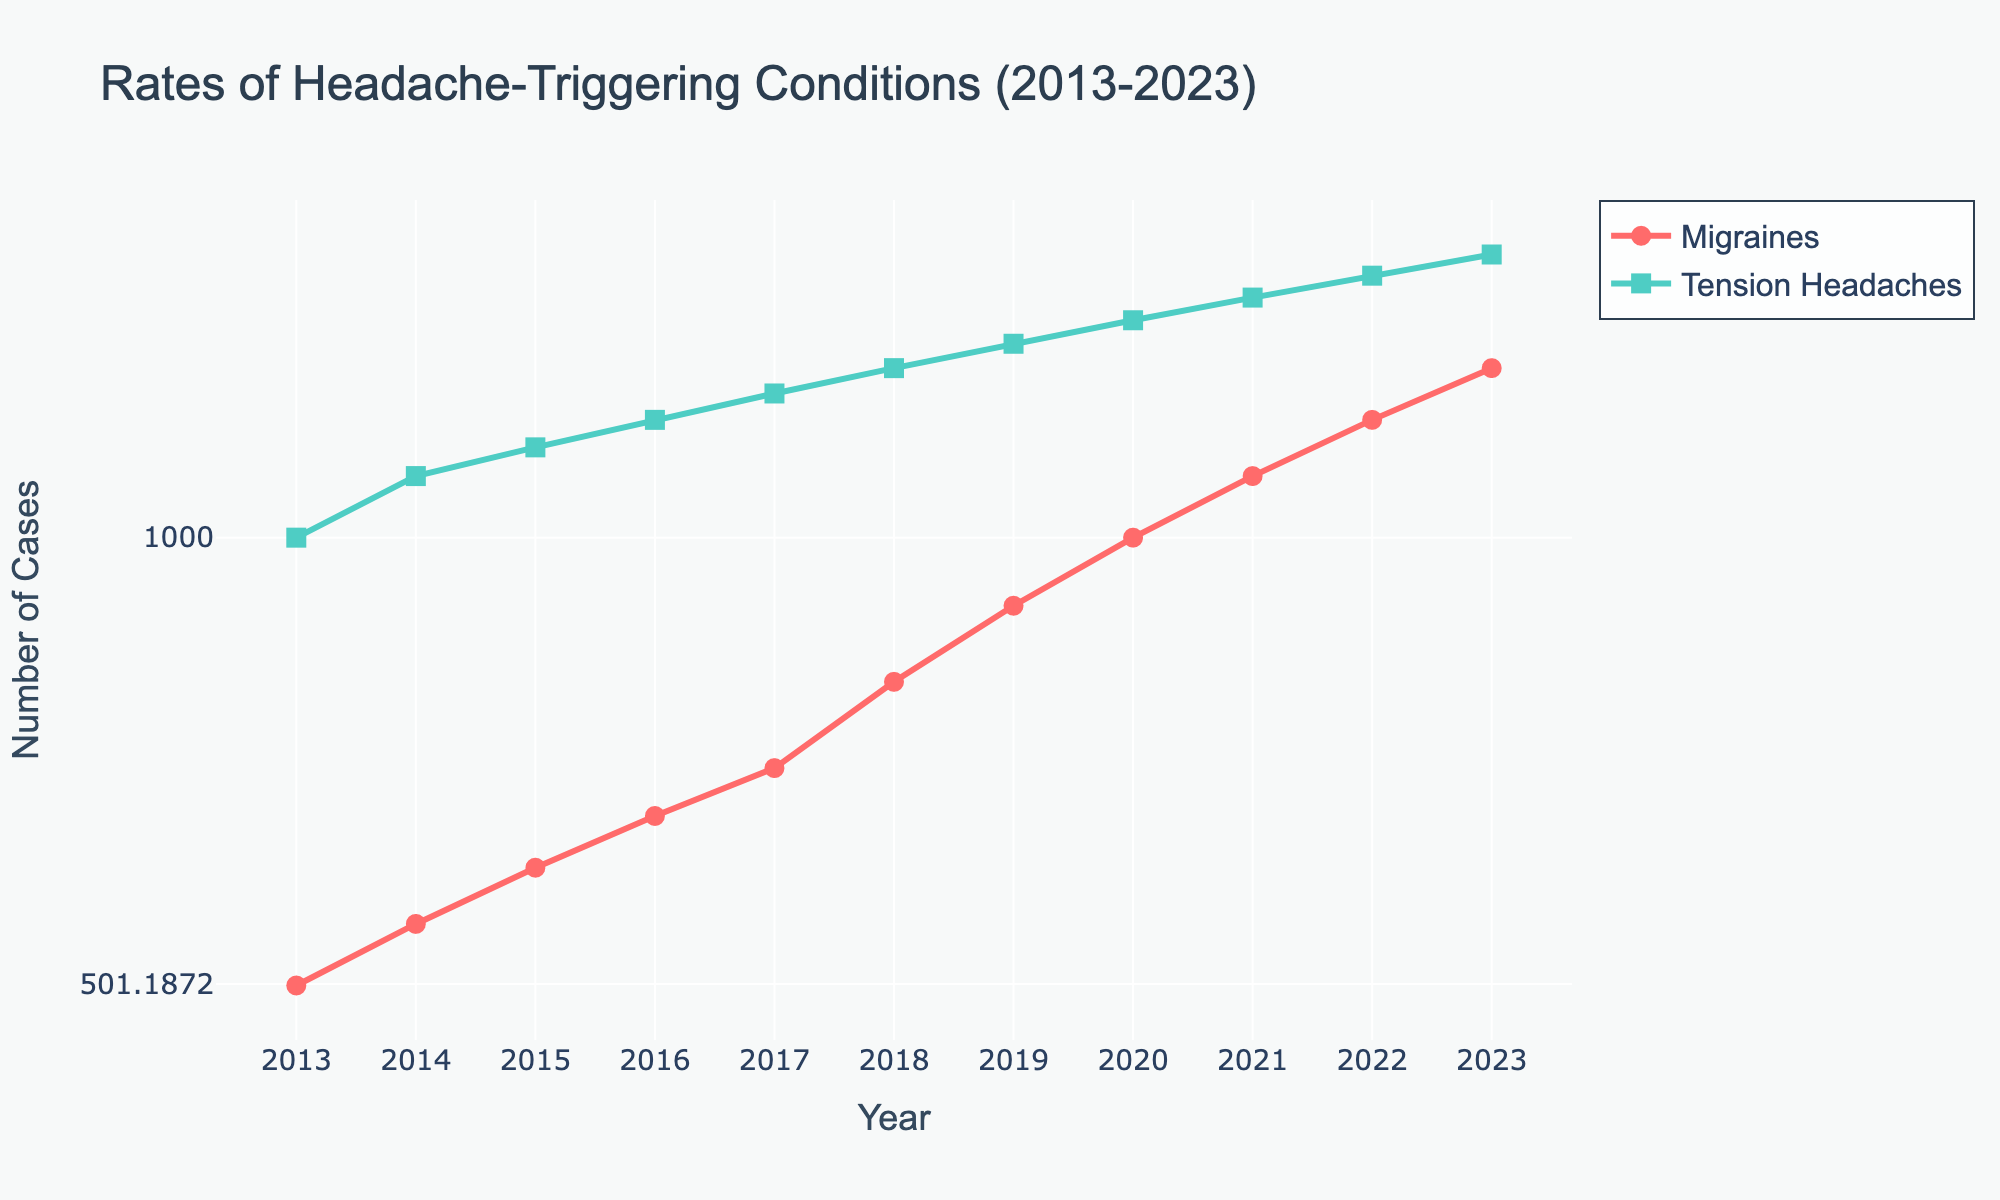What is the trend observed in the rate of migraines from 2013 to 2023? The line plot shows a consistent upward trend in the rate of migraines from 2013 to 2023. The number of cases increases each year as indicated by the data points connected with a line.
Answer: Upward trend What is the title of the figure? The title of the figure is mentioned at the top center of the plot.
Answer: Rates of Headache-Triggering Conditions (2013-2023) Which type of headache had more reported cases in 2017, migraines or tension headaches? By observing the y-values corresponding to 2017 on the respective lines, we see that tension headaches had more reported cases (approximately 1250) compared to migraines (approximately 700).
Answer: Tension headaches By what factor did the number of migraine cases change from 2013 to 2023? The number of migraine cases in 2013 was 500, and in 2023 it was 1300. The factor change is calculated as 1300/500.
Answer: 2.6 How many more cases of tension headaches were reported in 2023 compared to 2020? The number of tension headache cases in 2023 was 1550 and in 2020 it was 1400. The difference is 1550 - 1400.
Answer: 150 Which year had the highest number of migraine cases reported? The plot shows the highest y-value for the migraines line in the year 2023.
Answer: 2023 Are the y-axis values displayed on a linear or logarithmic scale, and how can you tell? The y-axis is on a logarithmic scale. This is evident because the increments between the tick values are not uniform and they span orders of magnitude rather than equal intervals.
Answer: Logarithmic What is the increment (difference) in the number of migraine cases from 2018 to 2019? The number of migraine cases in 2018 was 800 and in 2019 it was 900. The difference is 900 - 800.
Answer: 100 Is there any year where the number of migraine cases exceeds the number of tension headaches? By examining the plot, we see that in every year from 2013 to 2023, the number of tension headaches exceeds the number of migraine cases.
Answer: No What was the average number of tension headaches reported annually between 2013 and 2023? To get the average, sum up the number of tension headaches from 2013 to 2023 and then divide by the number of years (11). Sum = 1000 + 1100 + 1150 + 1200 + 1250 + 1300 + 1350 + 1400 + 1450 + 1500 + 1550 = 14050. The average is 14050/11.
Answer: 1277 